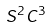Convert formula to latex. <formula><loc_0><loc_0><loc_500><loc_500>S ^ { 2 } C ^ { 3 }</formula> 